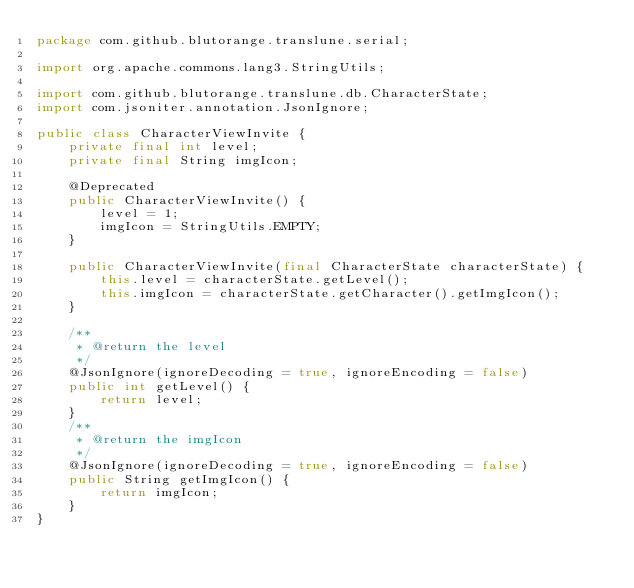<code> <loc_0><loc_0><loc_500><loc_500><_Java_>package com.github.blutorange.translune.serial;

import org.apache.commons.lang3.StringUtils;

import com.github.blutorange.translune.db.CharacterState;
import com.jsoniter.annotation.JsonIgnore;

public class CharacterViewInvite {
	private final int level;
	private final String imgIcon;

	@Deprecated
	public CharacterViewInvite() {
		level = 1;
		imgIcon = StringUtils.EMPTY;
	}

	public CharacterViewInvite(final CharacterState characterState) {
		this.level = characterState.getLevel();
		this.imgIcon = characterState.getCharacter().getImgIcon();
	}

	/**
	 * @return the level
	 */
	@JsonIgnore(ignoreDecoding = true, ignoreEncoding = false)
	public int getLevel() {
		return level;
	}
	/**
	 * @return the imgIcon
	 */
	@JsonIgnore(ignoreDecoding = true, ignoreEncoding = false)
	public String getImgIcon() {
		return imgIcon;
	}
}</code> 